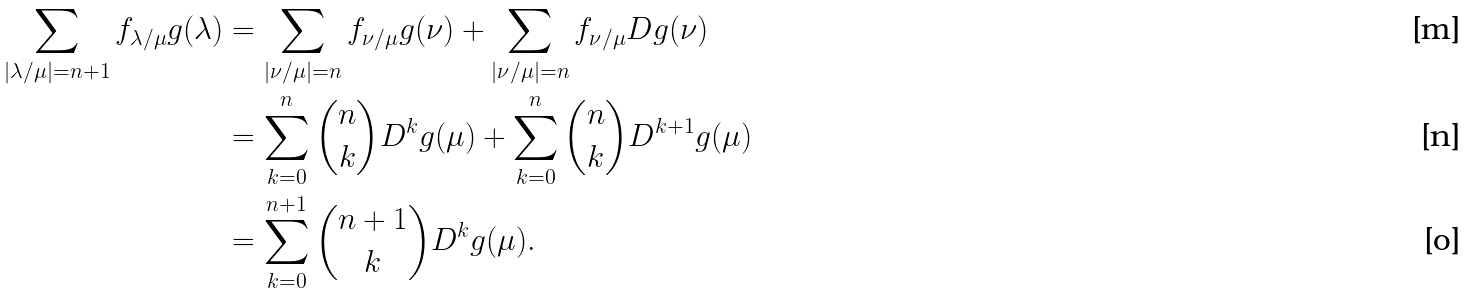Convert formula to latex. <formula><loc_0><loc_0><loc_500><loc_500>\sum _ { | \lambda / \mu | = n + 1 } f _ { \lambda / \mu } g ( \lambda ) & = \sum _ { | \nu / \mu | = n } f _ { \nu / \mu } g ( \nu ) + \sum _ { | \nu / \mu | = n } f _ { \nu / \mu } D g ( \nu ) \\ & = \sum _ { k = 0 } ^ { n } \binom { n } { k } D ^ { k } g ( \mu ) + \sum _ { k = 0 } ^ { n } \binom { n } { k } D ^ { k + 1 } g ( \mu ) \\ & = \sum _ { k = 0 } ^ { n + 1 } \binom { n + 1 } { k } D ^ { k } g ( \mu ) .</formula> 